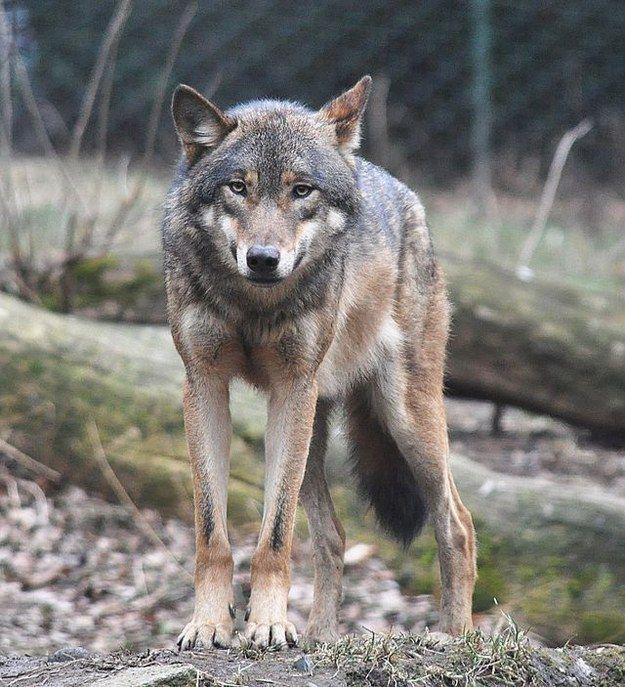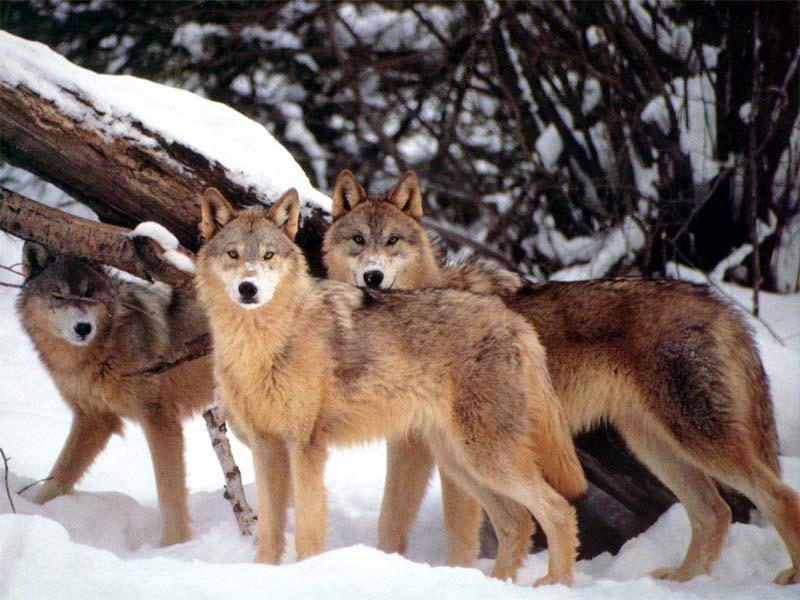The first image is the image on the left, the second image is the image on the right. Considering the images on both sides, is "There are at least three wolves walking through heavy snow." valid? Answer yes or no. Yes. 